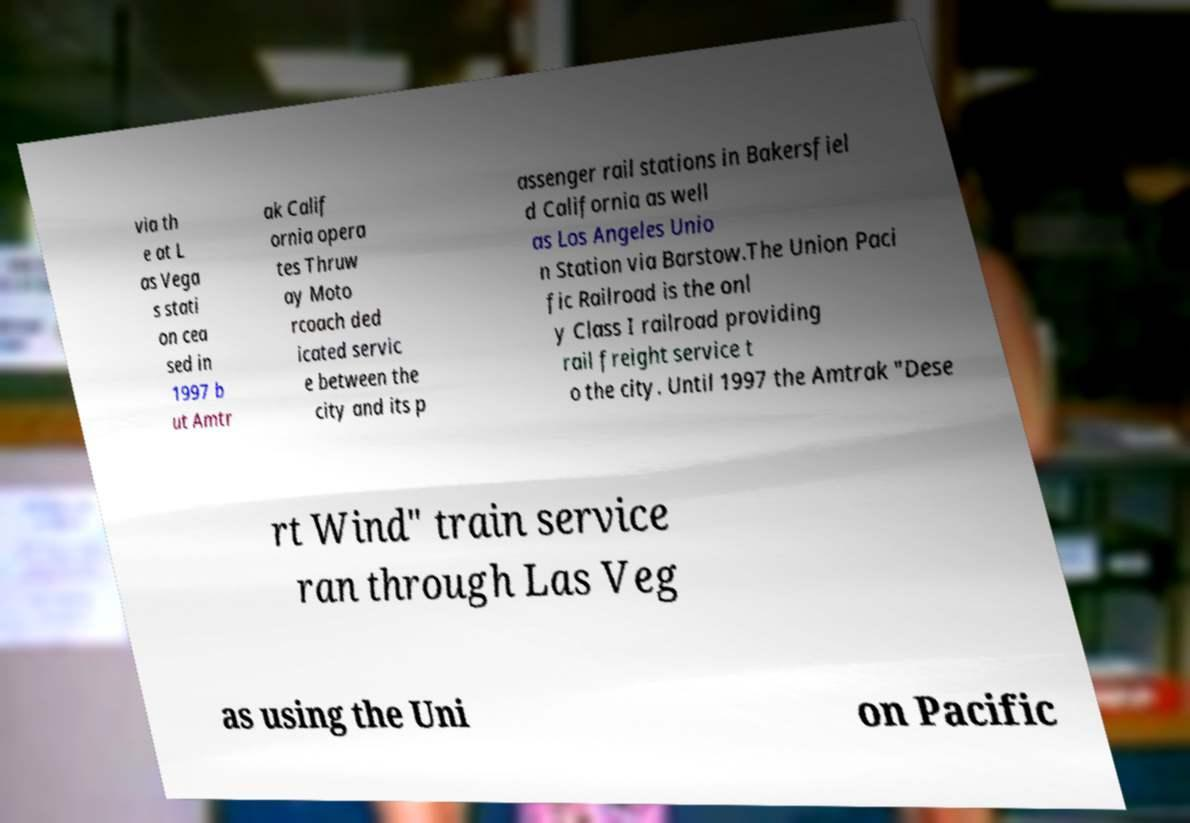What messages or text are displayed in this image? I need them in a readable, typed format. via th e at L as Vega s stati on cea sed in 1997 b ut Amtr ak Calif ornia opera tes Thruw ay Moto rcoach ded icated servic e between the city and its p assenger rail stations in Bakersfiel d California as well as Los Angeles Unio n Station via Barstow.The Union Paci fic Railroad is the onl y Class I railroad providing rail freight service t o the city. Until 1997 the Amtrak "Dese rt Wind" train service ran through Las Veg as using the Uni on Pacific 